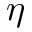Convert formula to latex. <formula><loc_0><loc_0><loc_500><loc_500>\eta</formula> 